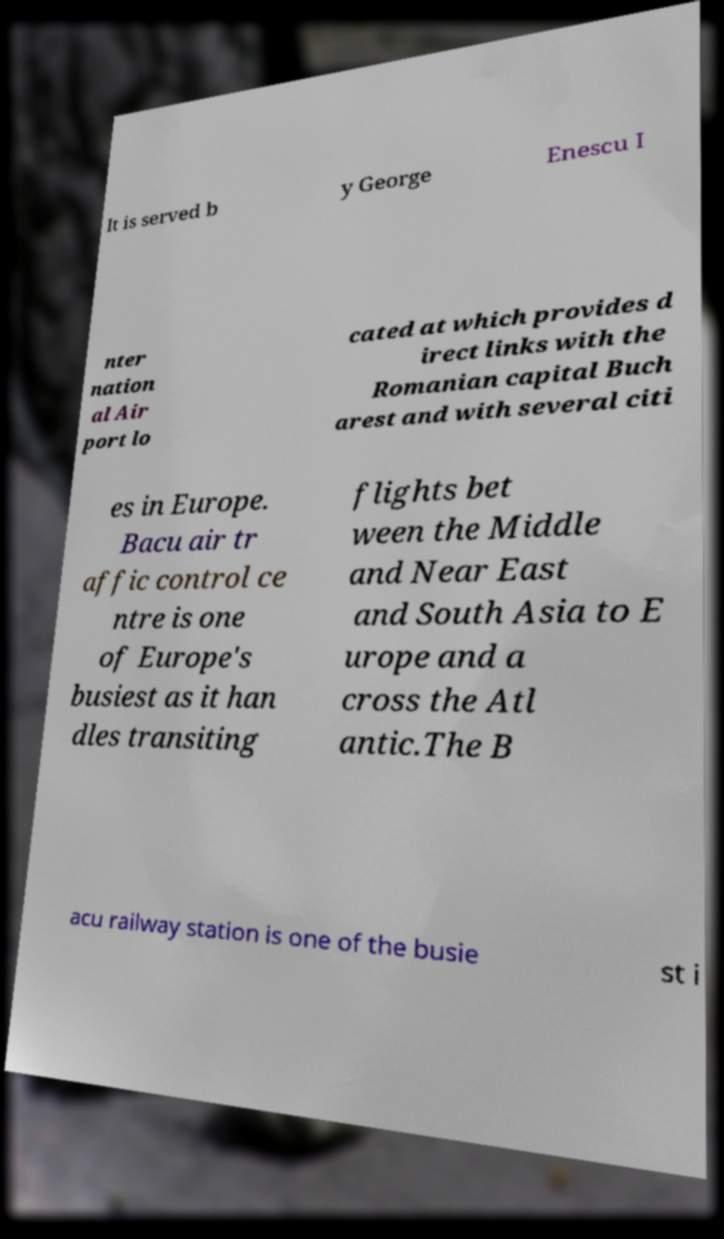Please identify and transcribe the text found in this image. It is served b y George Enescu I nter nation al Air port lo cated at which provides d irect links with the Romanian capital Buch arest and with several citi es in Europe. Bacu air tr affic control ce ntre is one of Europe's busiest as it han dles transiting flights bet ween the Middle and Near East and South Asia to E urope and a cross the Atl antic.The B acu railway station is one of the busie st i 